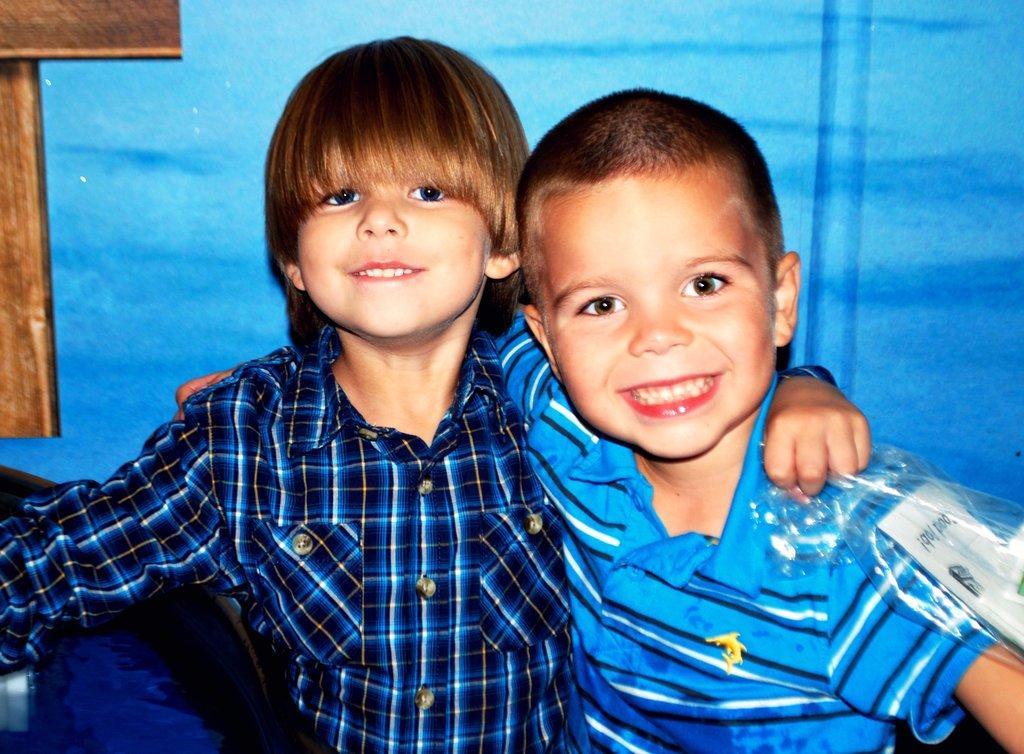Please provide a concise description of this image. In the image there are two boys smiling and posing for the photo and behind them there is a blue background, on the left side there is some wooden object. 